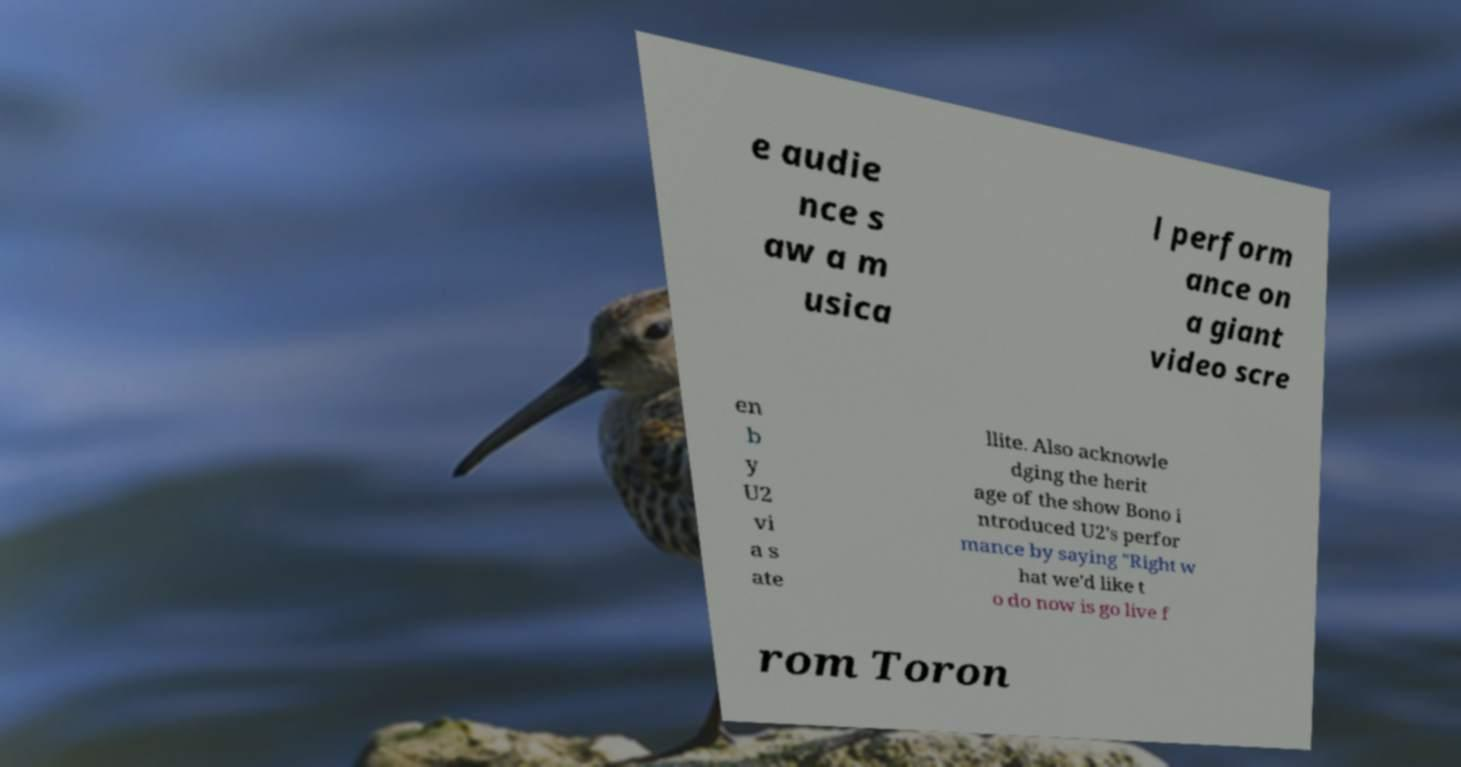For documentation purposes, I need the text within this image transcribed. Could you provide that? e audie nce s aw a m usica l perform ance on a giant video scre en b y U2 vi a s ate llite. Also acknowle dging the herit age of the show Bono i ntroduced U2's perfor mance by saying "Right w hat we'd like t o do now is go live f rom Toron 